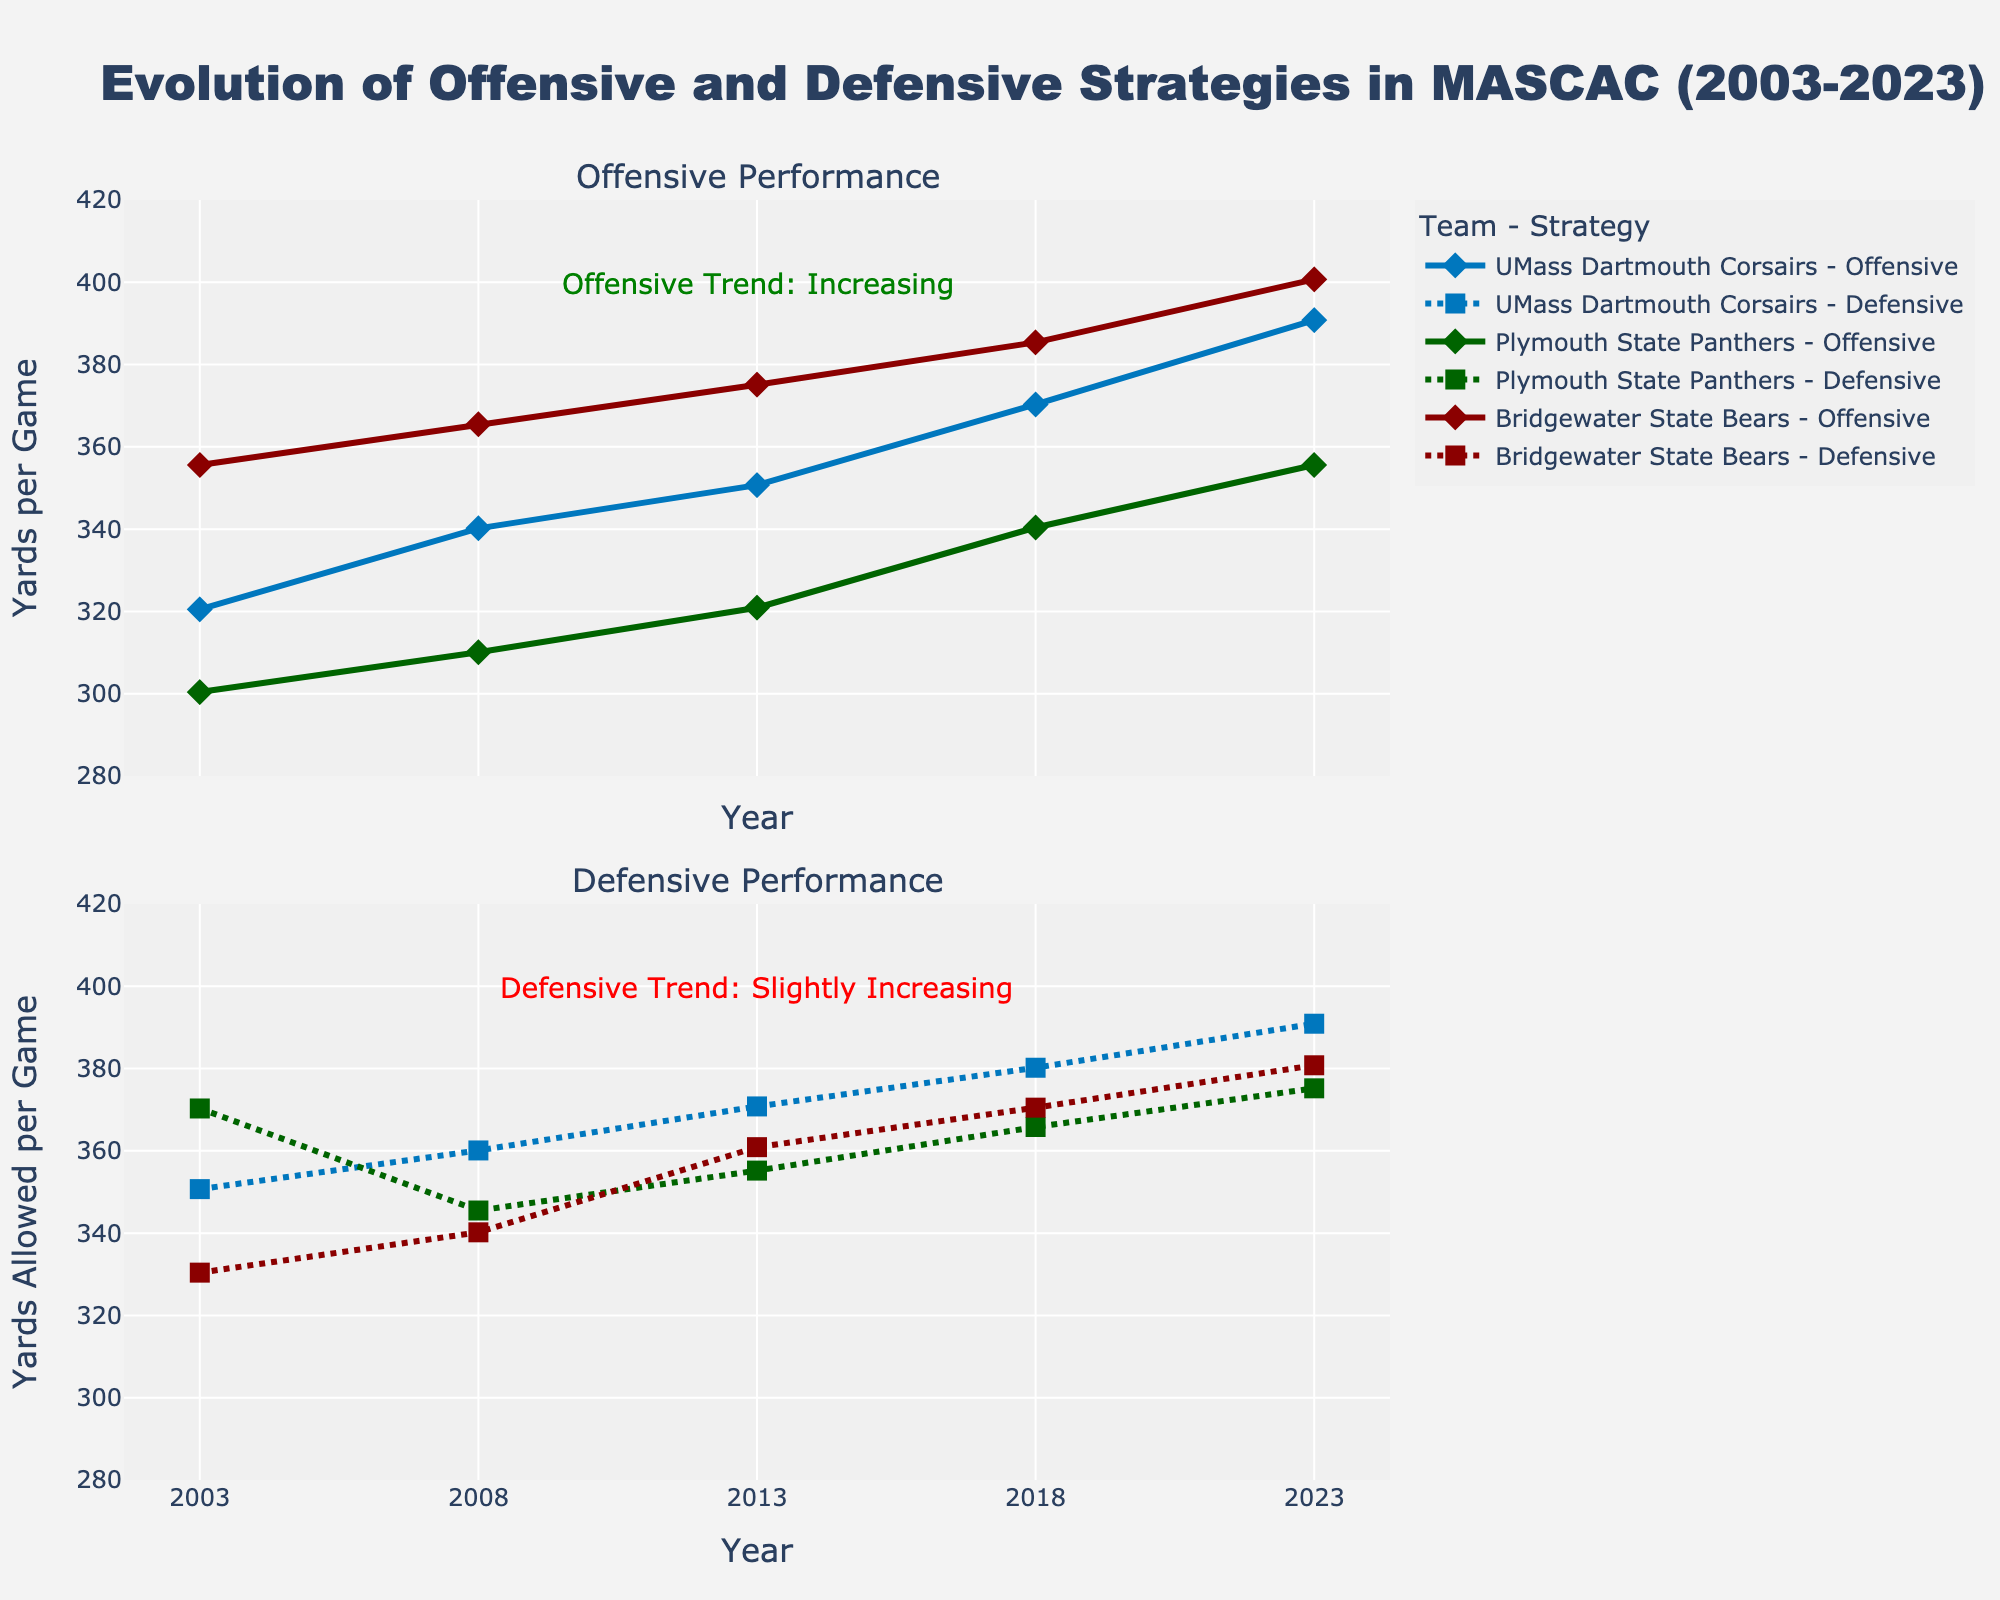What is the title of the figure? The title of the figure is typically found at the top of the chart and gives an overall description of what the plot represents. In this case, it should clearly state the context of the data shown.
Answer: Evolution of Offensive and Defensive Strategies in MASCAC (2003-2023) Which team had the highest offensive yards per game in 2023? To determine this, look at the offensive yards per game for each team in 2023 in the first subplot (Offensive Performance). Identify the highest value.
Answer: Bridgewater State Bears How did UMass Dartmouth Corsairs' offensive yards per game change from 2003 to 2023? Check UMass Dartmouth Corsairs' offensive performance line in the first subplot. Compare the values at 2003 and 2023 to see the change.
Answer: Increased What is the general trend for defensive yards allowed per game from 2003 to 2023 for all teams? To answer this, observe the overall pattern of the defensive lines for all teams in the second subplot. Notice if the values are generally increasing, decreasing, or stable.
Answer: Slightly increasing Which team showed the most significant improvement in points scored per game from 2003 to 2023? Examine the points scored per game for each team in the data provided. Calculate the difference between 2023 and 2003 for each team and compare.
Answer: Bridgewater State Bears What are the colors representing the UMass Dartmouth Corsairs in the plot? Look at the lines and markers representing UMass Dartmouth Corsairs in both subplots. The color used for this team should be consistent.
Answer: Blue Compare the offensive yards per game for Bridgewater State Bears in 2003 and 2018. Which year had higher values? Check Bridgewater State Bears' offensive performance line in the first subplot. Locate the values for 2003 and 2018 and compare them.
Answer: 2018 By how much did Plymouth State Panthers improve their defensive yards per game from 2003 to 2023? Find Plymouth State Panthers' defensive yards in 2003 and 2023 in the second subplot. Subtract the 2023 value from the 2003 value to find the improvement.
Answer: 5.1 yards What annotation is added to indicate trends in the plot? Look for text annotations in both subplots that describe trends in the data, such as descriptions or observations.
Answer: Offensive Trend: Increasing, Defensive Trend: Slightly Increasing 